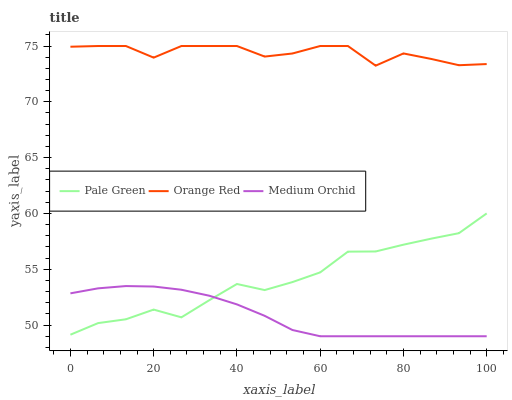Does Medium Orchid have the minimum area under the curve?
Answer yes or no. Yes. Does Orange Red have the maximum area under the curve?
Answer yes or no. Yes. Does Pale Green have the minimum area under the curve?
Answer yes or no. No. Does Pale Green have the maximum area under the curve?
Answer yes or no. No. Is Medium Orchid the smoothest?
Answer yes or no. Yes. Is Orange Red the roughest?
Answer yes or no. Yes. Is Pale Green the smoothest?
Answer yes or no. No. Is Pale Green the roughest?
Answer yes or no. No. Does Medium Orchid have the lowest value?
Answer yes or no. Yes. Does Pale Green have the lowest value?
Answer yes or no. No. Does Orange Red have the highest value?
Answer yes or no. Yes. Does Pale Green have the highest value?
Answer yes or no. No. Is Pale Green less than Orange Red?
Answer yes or no. Yes. Is Orange Red greater than Medium Orchid?
Answer yes or no. Yes. Does Medium Orchid intersect Pale Green?
Answer yes or no. Yes. Is Medium Orchid less than Pale Green?
Answer yes or no. No. Is Medium Orchid greater than Pale Green?
Answer yes or no. No. Does Pale Green intersect Orange Red?
Answer yes or no. No. 